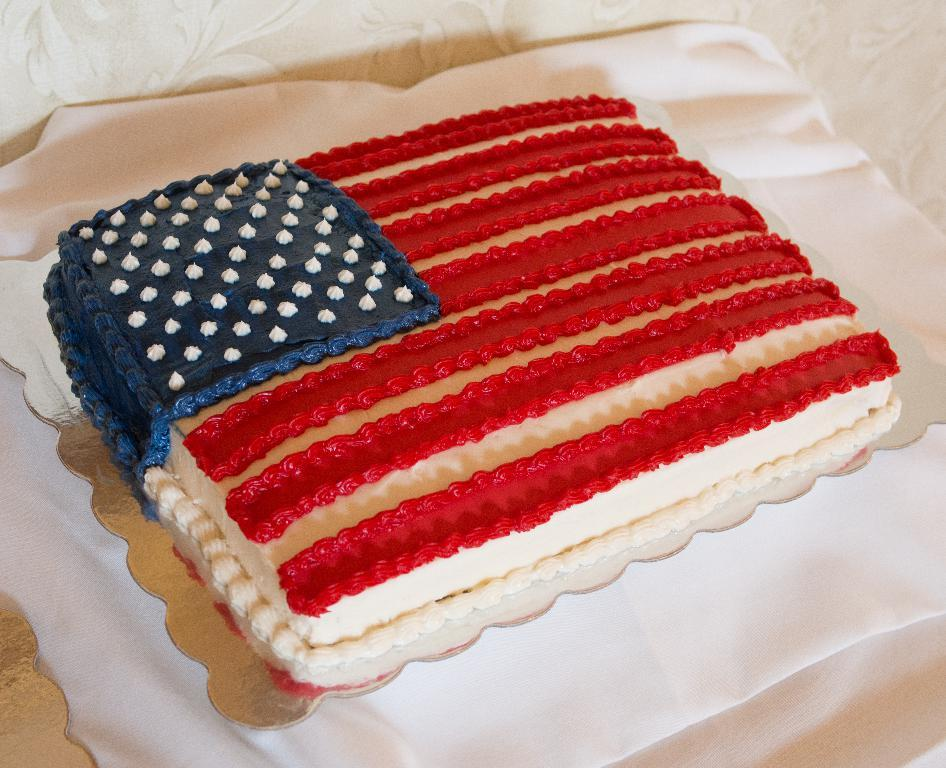What is the main subject in the center of the image? There is a cake in the center of the image. What is located at the bottom of the image? There is a white cloth at the bottom of the image. What type of corn can be seen growing in space in the image? There is no corn or space present in the image; it features a cake and a white cloth. 